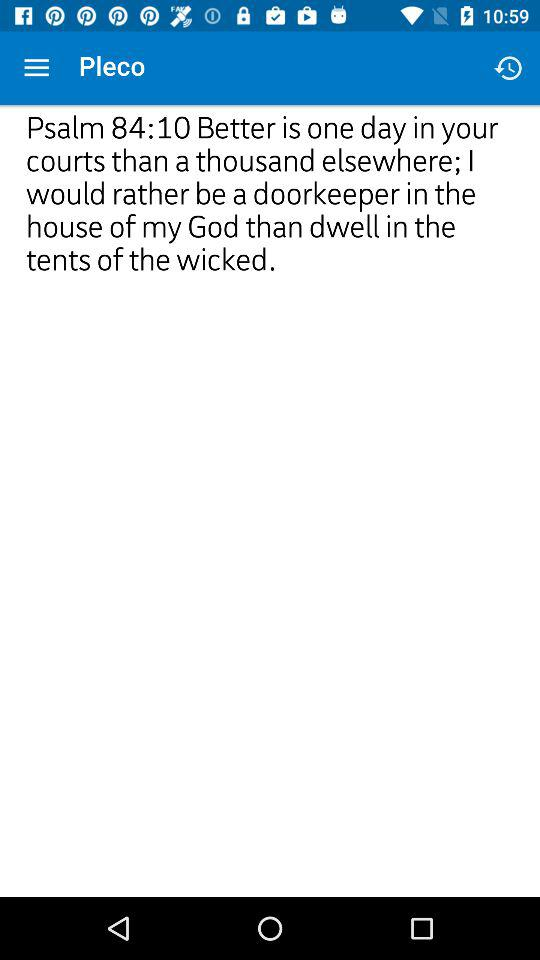What is the app name? The app name is "Pleco". 